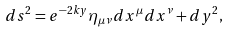Convert formula to latex. <formula><loc_0><loc_0><loc_500><loc_500>d s ^ { 2 } = e ^ { - 2 k y } \eta _ { \mu \nu } d x ^ { \mu } d x ^ { \nu } + d y ^ { 2 } ,</formula> 